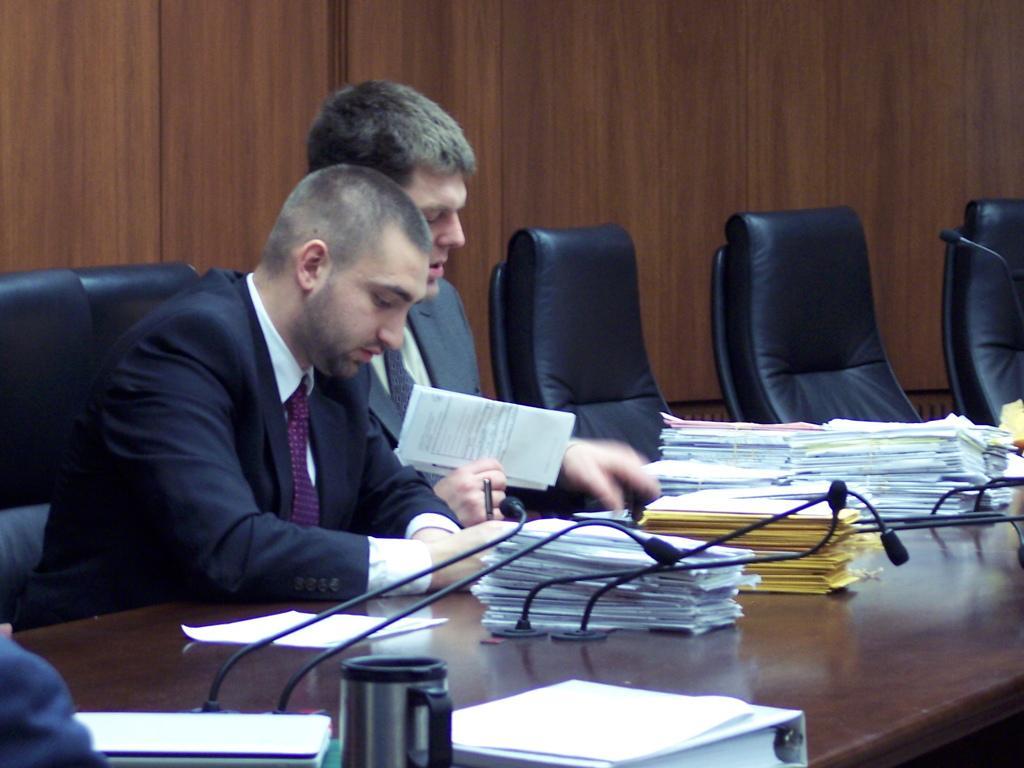Describe this image in one or two sentences. In this picture we can see two men sitting on chairs in front of a table and on the table we can see mug, file, papers, mike's. These are empty chairs. We can see this man is holding papers in his hand. This man is holding a pen in his hand. 